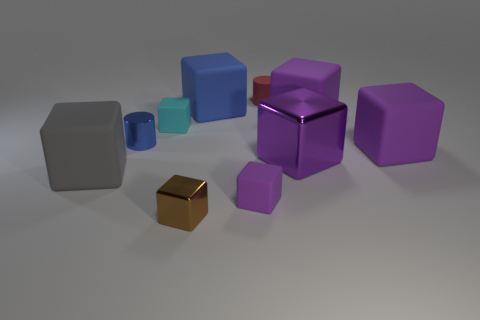How many purple blocks must be subtracted to get 1 purple blocks? 3 Subtract all brown cylinders. How many purple cubes are left? 4 Subtract all small shiny blocks. How many blocks are left? 7 Subtract 2 cubes. How many cubes are left? 6 Subtract all brown cubes. How many cubes are left? 7 Subtract all gray blocks. Subtract all cyan spheres. How many blocks are left? 7 Subtract all cylinders. How many objects are left? 8 Subtract 1 blue cylinders. How many objects are left? 9 Subtract all small brown objects. Subtract all tiny metal cylinders. How many objects are left? 8 Add 4 big gray matte objects. How many big gray matte objects are left? 5 